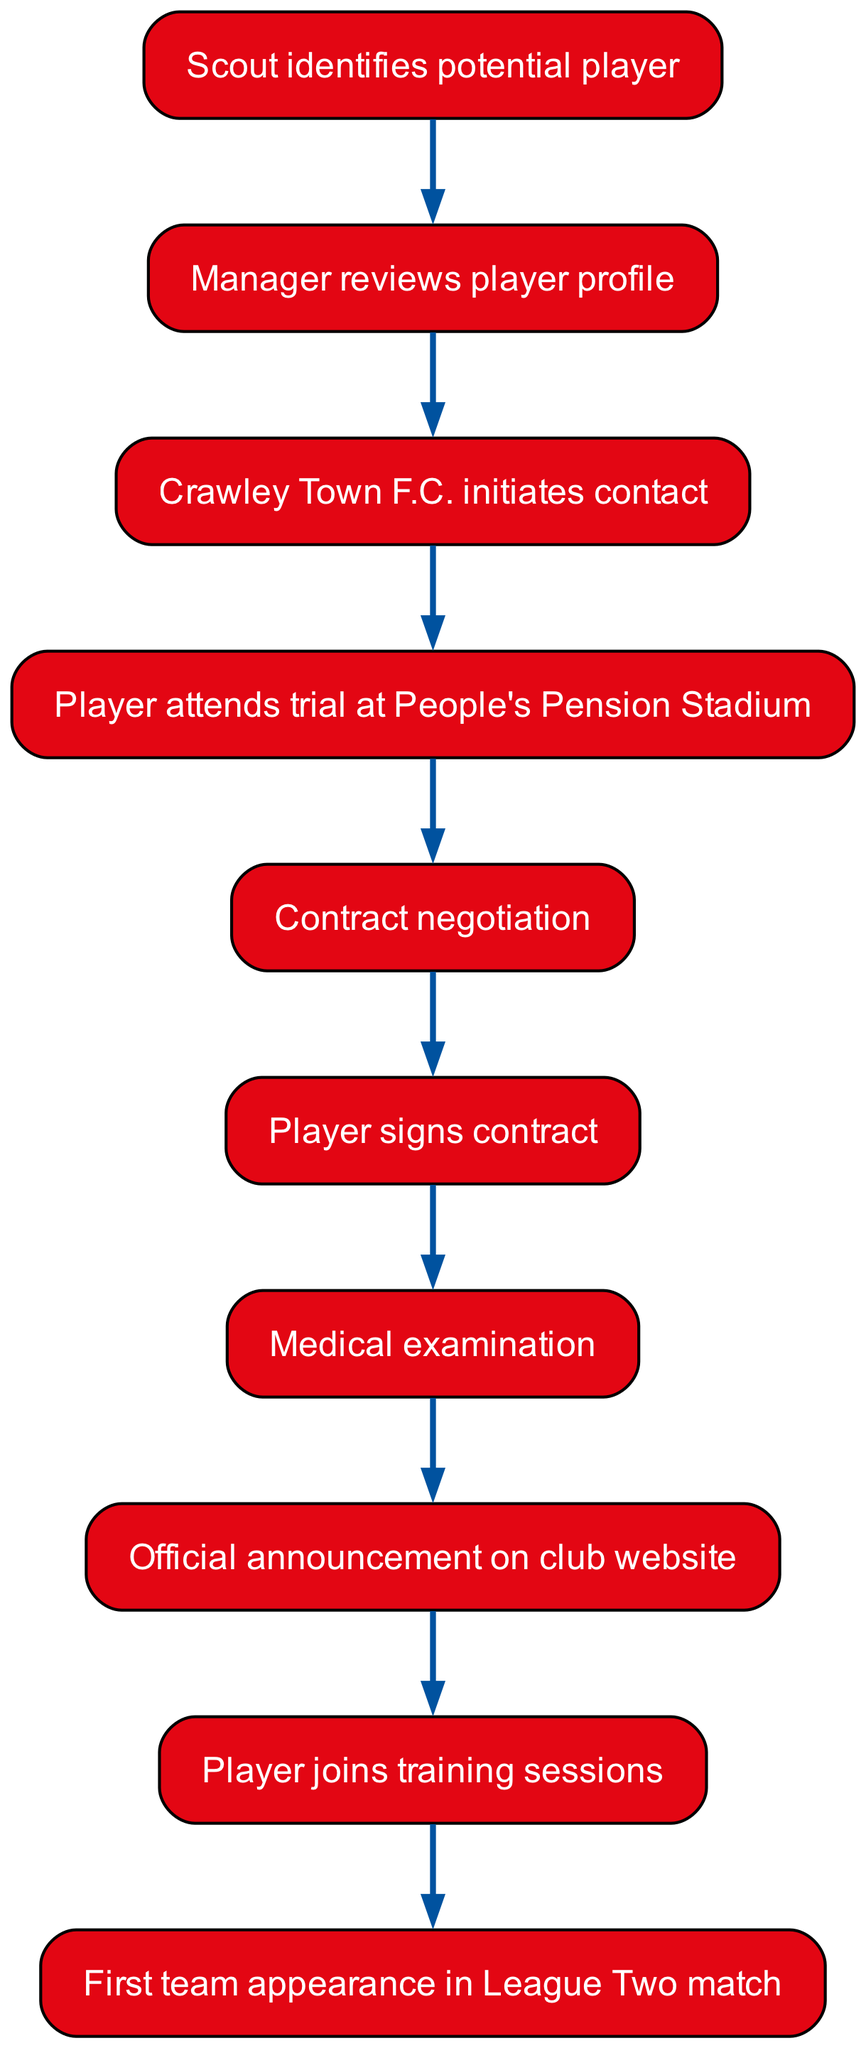What is the first step in the player signing process? The first step is "Scout identifies potential player." This is the very first node in the diagram, indicating the initiation of the player signing process.
Answer: Scout identifies potential player How many total steps are shown in the diagram? The diagram contains a total of ten steps, with each step representing a specific part of the signing process, including the last step which is the player's first team appearance.
Answer: 10 What happens immediately after the contract negotiation? Immediately after "Contract negotiation," the next step is "Player signs contract." This is indicated by the directed edge moving from the contract negotiation node to the player signing node.
Answer: Player signs contract Which node follows the medical examination? The node that follows "Medical examination" is "Official announcement on club website." This can be traced in the flow of the diagram, where the medical examination leads directly to the official announcement.
Answer: Official announcement on club website Which event concludes the signing process for a player? The signing process concludes with "First team appearance in League Two match." This is the last node in the flowchart, representing the final step of the journey for a player signing with Crawley Town F.C.
Answer: First team appearance in League Two match What is the relationship between the "Player attends trial at People's Pension Stadium" and "Contract negotiation"? The relationship is sequential; the "Player attends trial at People's Pension Stadium" occurs before "Contract negotiation." This indicates that the trial is a prerequisite step before negotiations can commence.
Answer: Sequential relationship What is the purpose of the "Manager reviews player profile" step? The purpose of "Manager reviews player profile" is to evaluate whether the identified player by the scout should move forward in the signing process. It serves as a decision point to determine the next steps.
Answer: Evaluation of player suitability What happens after the official announcement on the club website? After the "Official announcement on club website," the player then "joins training sessions." This indicates that following the announcement, the player begins preparing with the team.
Answer: Joins training sessions What does the flowchart indicate happens before a player can sign a contract? Before a player can sign a contract, there must be "Contract negotiation." This is a crucial step that occurs right after the player attends the trial and indicates the terms must be discussed before a signing occurs.
Answer: Contract negotiation 